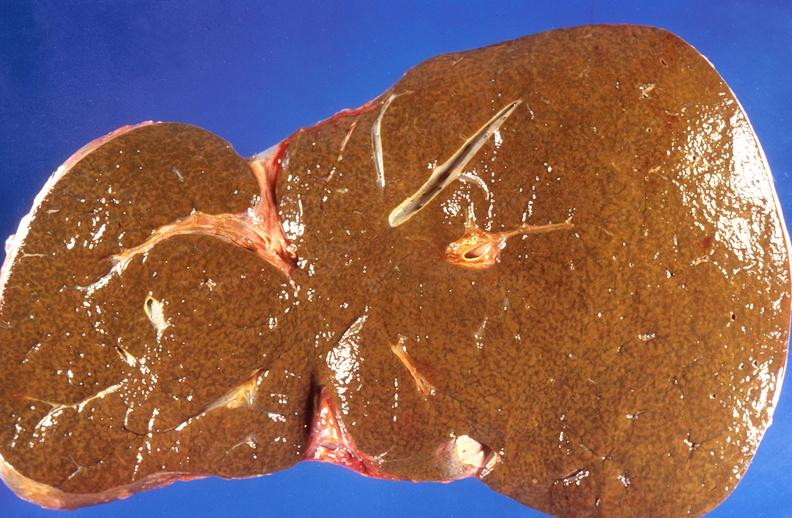does close-up of lesion show liver, cholestasis and cirrhosis in a patient with cystic fibrosis?
Answer the question using a single word or phrase. No 